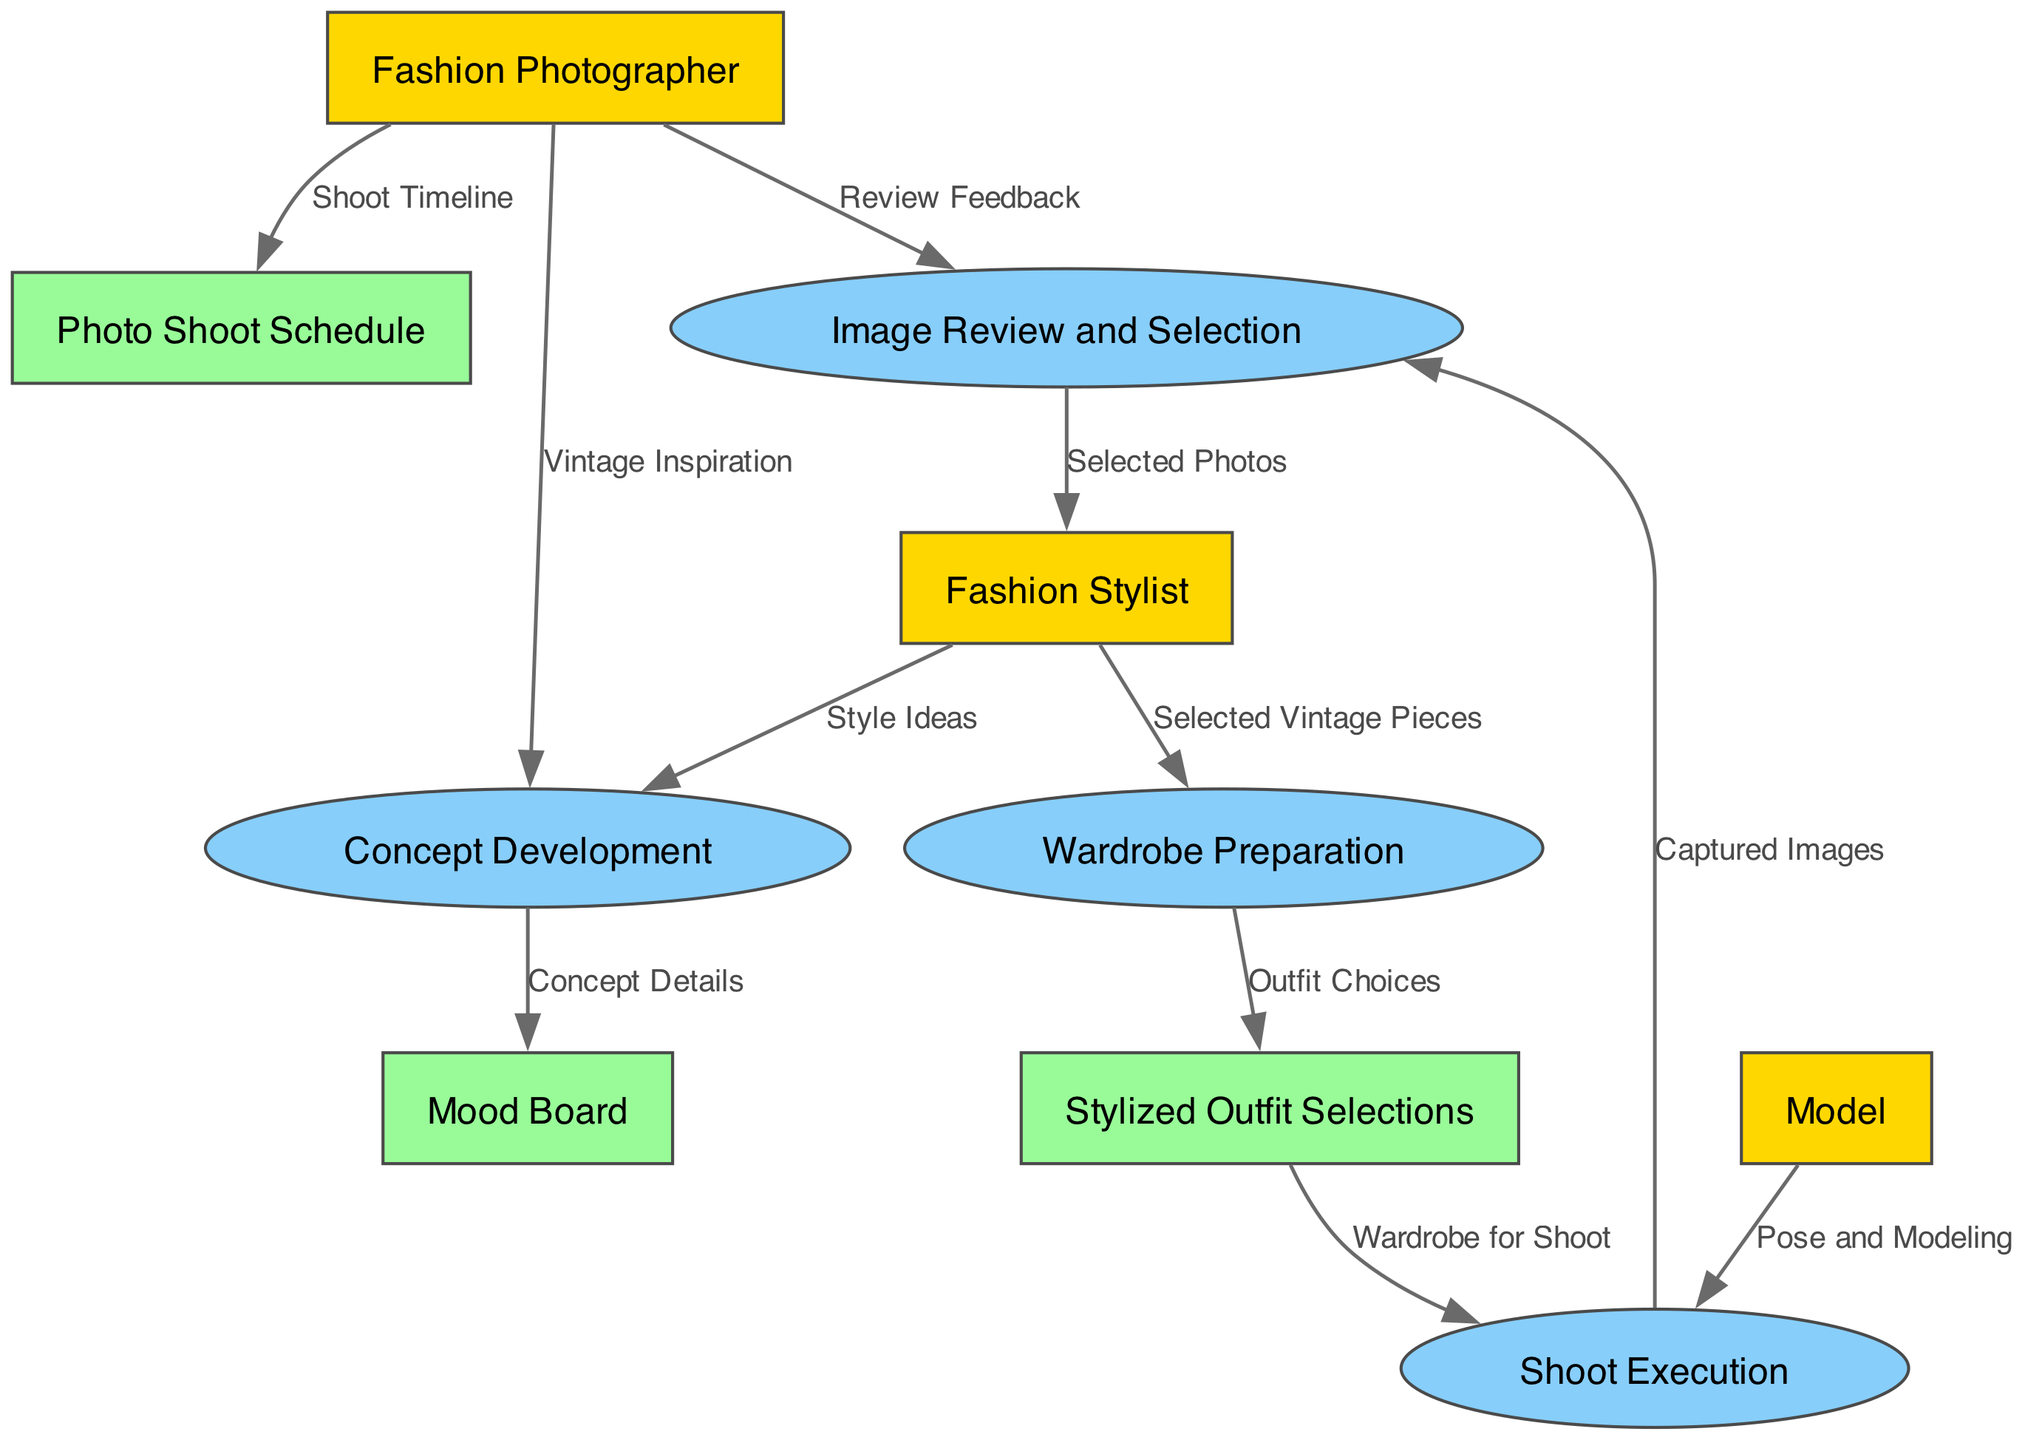What are the external entities involved in the collaboration process? The diagram identifies three external entities: Fashion Photographer, Fashion Stylist, and Model. These are clearly shown in the entities section of the diagram.
Answer: Fashion Photographer, Fashion Stylist, Model How many data stores are represented in the diagram? The diagram includes three data stores: Mood Board, Stylized Outfit Selections, and Photo Shoot Schedule. This can be verified by counting the data store entries in the entities section.
Answer: Three What data does the Fashion Photographer provide to the Concept Development process? The Fashion Photographer supplies "Vintage Inspiration" as input to the Concept Development process, indicated by the data flow from this external entity to the respective process.
Answer: Vintage Inspiration In which process is "Selected Vintage Pieces" data used? "Selected Vintage Pieces" is utilized in the Wardrobe Preparation process, as shown by the data flow from the Fashion Stylist to this process.
Answer: Wardrobe Preparation Which entity receives the "Review Feedback" from the Image Review and Selection process? The "Review Feedback" from the Image Review and Selection process is directed to the Fashion Photographer, indicating that the Photographer assesses the captured images.
Answer: Fashion Photographer What is the final output of the collaboration process shown in the diagram? The final output is the "Selected Photos," which are delivered to the Fashion Stylist as the culmination of the Image Review and Selection process, indicating the conclusion of their collaboration.
Answer: Selected Photos How many total data flows are indicated in the diagram? The diagram shows a total of ten data flows, which can be confirmed by counting the connections between entities and processes represented in the data flow section.
Answer: Ten Which process is responsible for capturing images? The "Shoot Execution" process is designated for capturing images during the shoot, as indicated by the relevant data flows from the Model and Stylized Outfit Selections.
Answer: Shoot Execution How does the Mood Board relate to the Concept Development process? The Mood Board receives "Concept Details" as output from the Concept Development process, showing its role in visually representing the developed ideas.
Answer: Mood Board 